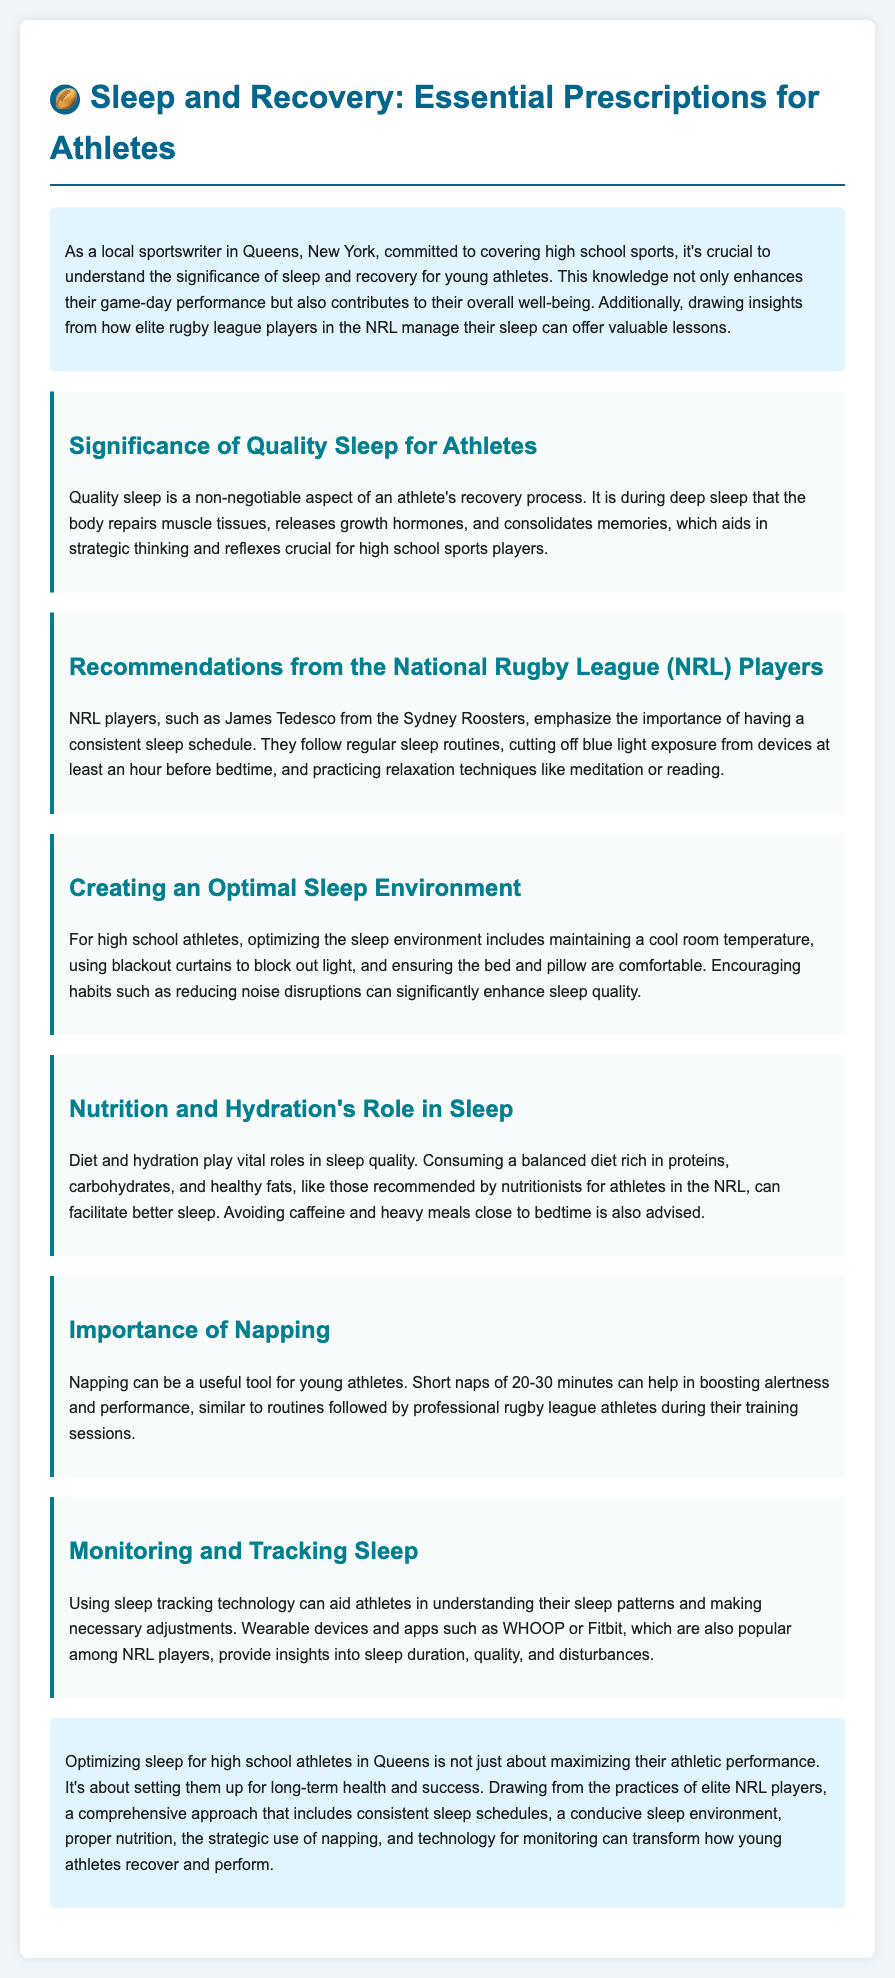What is the primary focus of the document? The document is about optimizing athlete sleep patterns for peak performance.
Answer: optimizing athlete sleep patterns for peak performance Who is mentioned as an example of an NRL player? James Tedesco from the Sydney Roosters is provided as an example of an NRL player.
Answer: James Tedesco What should athletes avoid consuming close to bedtime? The document advises avoiding caffeine and heavy meals close to bedtime.
Answer: caffeine and heavy meals How long should a short nap ideally last? The document states that short naps should ideally last 20-30 minutes.
Answer: 20-30 minutes What plays a vital role in sleep quality according to the document? Diet and hydration are stated as playing vital roles in sleep quality.
Answer: Diet and hydration What is recommended to block out light in an athlete's sleep environment? Using blackout curtains is recommended to block out light.
Answer: blackout curtains What technology is suggested for monitoring sleep? Wearable devices and apps like WHOOP or Fitbit are suggested for monitoring sleep.
Answer: WHOOP or Fitbit What is the aim of optimizing sleep for high school athletes? The aim of optimizing sleep is to set them up for long-term health and success.
Answer: long-term health and success 